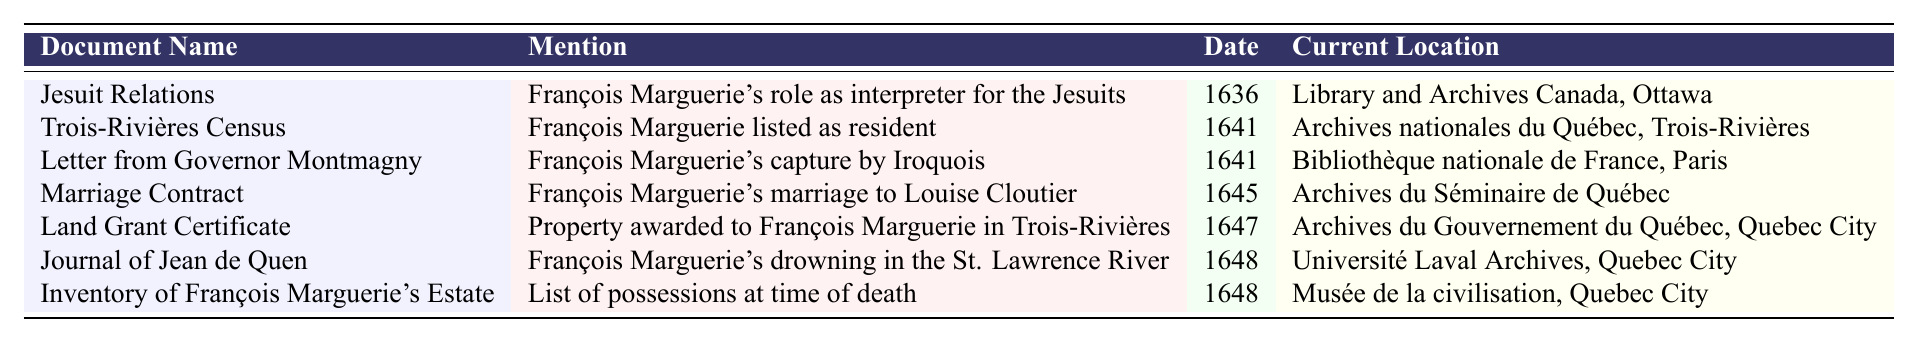What document mentions François Marguerie's role as an interpreter for the Jesuits? The table lists "Jesuit Relations" as the document that mentions François Marguerie's role as an interpreter.
Answer: Jesuit Relations Which document is associated with François Marguerie's marriage? The Marriage Contract has been documented as the document associated with François Marguerie's marriage to Louise Cloutier.
Answer: Marriage Contract In what year was François Marguerie listed as a resident in the Trois-Rivières Census? According to the table, François Marguerie was listed as a resident in the year 1641 in the Trois-Rivières Census.
Answer: 1641 What is the current location of the "Letter from Governor Montmagny"? The current location stated for the "Letter from Governor Montmagny" is the Bibliothèque nationale de France, Paris.
Answer: Bibliothèque nationale de France, Paris How many documents are dated from the year 1641? Two documents are listed for the year 1641: the Trois-Rivières Census and the Letter from Governor Montmagny.
Answer: 2 True or False: François Marguerie's drowning is mentioned in the Journal of Jean de Quen. The table indicates that the Journal of Jean de Quen mentions François Marguerie's drowning in the St. Lawrence River, which means the statement is true.
Answer: True Which document has the most recent date of mention for François Marguerie? The Inventory of François Marguerie's Estate has the most recent date of mention listed in the table, which is 1648.
Answer: Inventory of François Marguerie's Estate What locations are associated with documents dated 1648? The documents dated 1648 are the Journal of Jean de Quen and the Inventory of François Marguerie's Estate. Their locations are Université Laval Archives and Musée de la civilisation, respectively.
Answer: Université Laval Archives and Musée de la civilisation Which document mentions François Marguerie’s capture? The document mentioning François Marguerie’s capture by the Iroquois is the "Letter from Governor Montmagny."
Answer: Letter from Governor Montmagny What is the significance of the Land Grant Certificate? The Land Grant Certificate signifies that property was awarded to François Marguerie in Trois-Rivières, which is historical information about his land ownership.
Answer: Property awarded in Trois-Rivières 